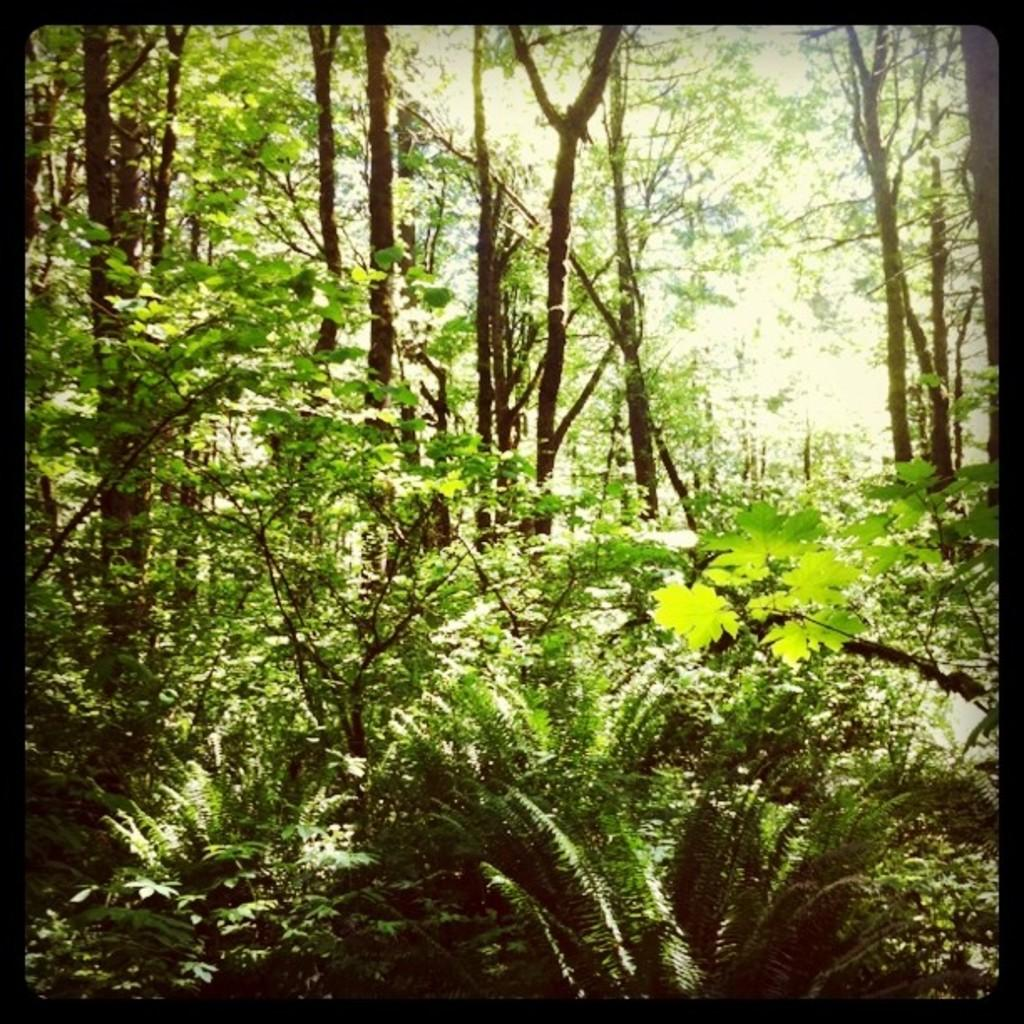What type of natural elements can be seen in the image? There are trees in the image. What is the color of the border surrounding the image? The image has a black color border. How many toes are visible in the image? There are no toes visible in the image, as it only features trees and a black border. 